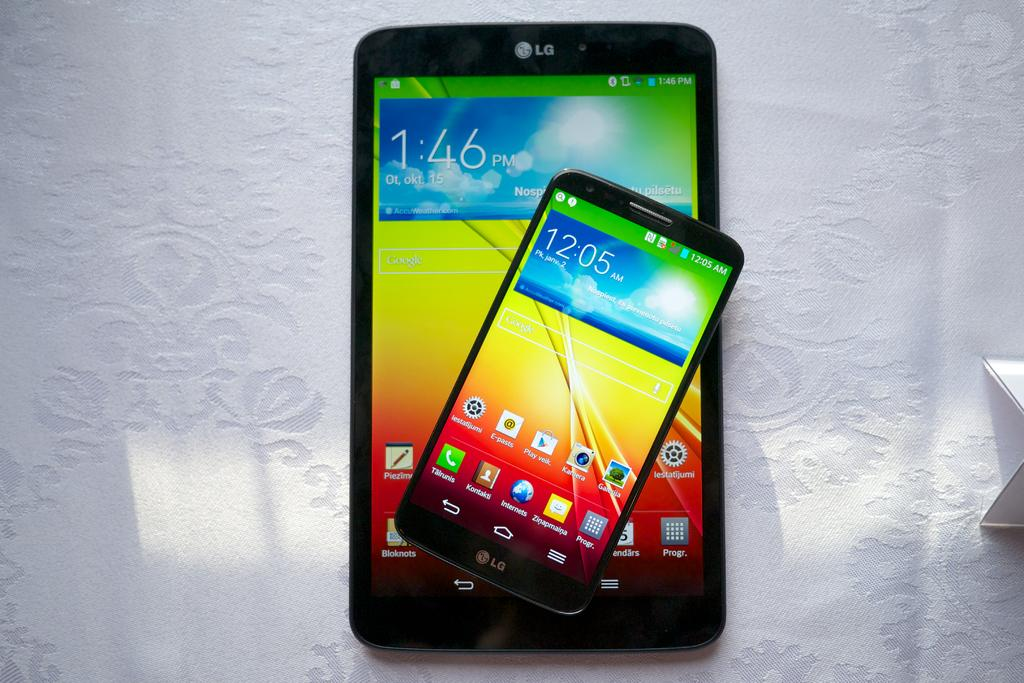How many mobiles can be seen in the image? There are two mobiles in the image. What is the color of the surface on which the mobiles are placed? The mobiles are on a white color surface. What can be observed on the screens of the mobiles? There are icons visible on the mobiles. Can you hear the mobiles crying in the image? Mobiles do not have the ability to cry, so there is no crying heard in the image. 